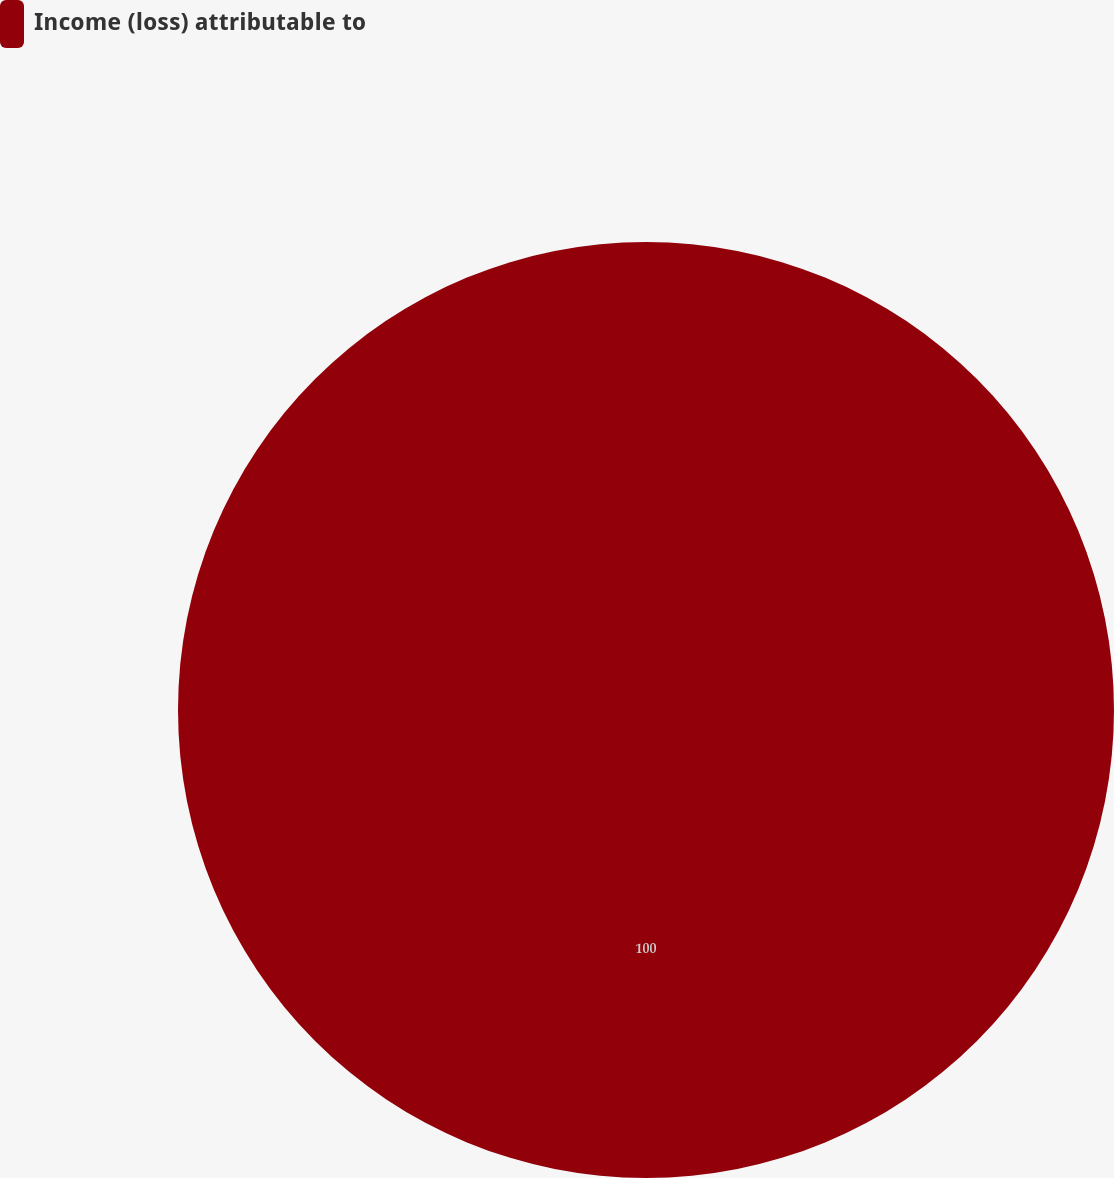Convert chart. <chart><loc_0><loc_0><loc_500><loc_500><pie_chart><fcel>Income (loss) attributable to<nl><fcel>100.0%<nl></chart> 